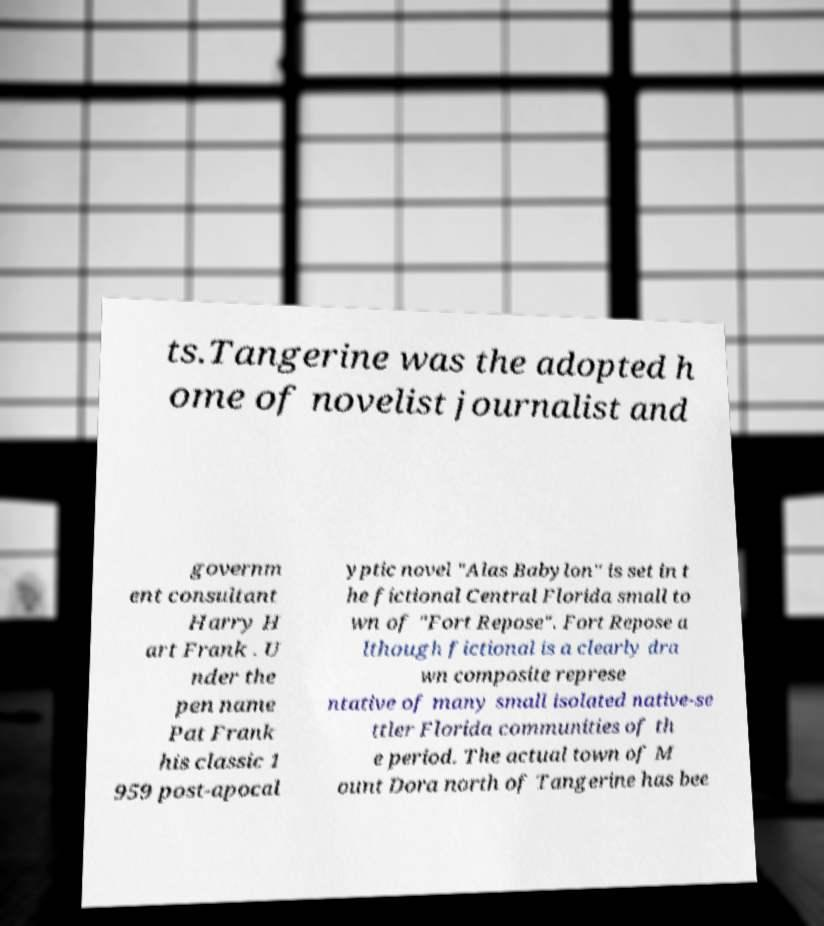What messages or text are displayed in this image? I need them in a readable, typed format. ts.Tangerine was the adopted h ome of novelist journalist and governm ent consultant Harry H art Frank . U nder the pen name Pat Frank his classic 1 959 post-apocal yptic novel "Alas Babylon" is set in t he fictional Central Florida small to wn of "Fort Repose". Fort Repose a lthough fictional is a clearly dra wn composite represe ntative of many small isolated native-se ttler Florida communities of th e period. The actual town of M ount Dora north of Tangerine has bee 